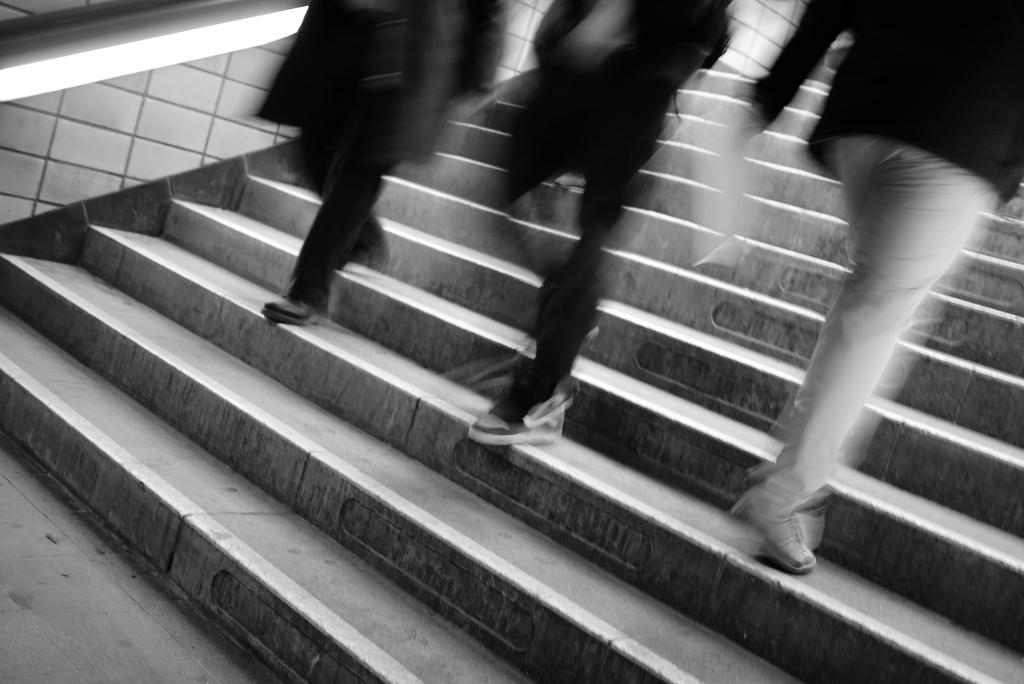What is the color scheme of the image? The image is black and white. How many people are in the image? There are three persons in the image. Where are the persons located in the image? The persons are on the steps. What is the name of the carriage that the persons are riding in the image? There is no carriage present in the image; the persons are on the steps. What thoughts are going through the minds of the persons in the image? We cannot determine the thoughts of the persons in the image based on the provided facts. 